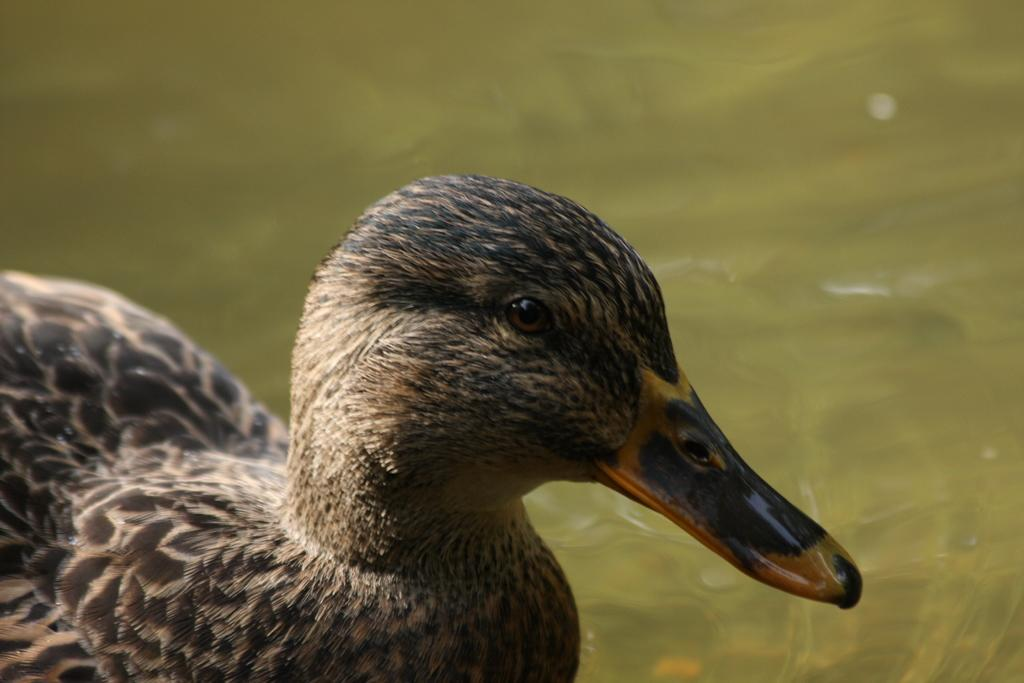What animal is present in the image? There is a duck in the image. Where is the duck located? The duck is on the water. What historical event is depicted in the image involving the duck and an oven? There is no historical event, duck, or oven present in the image. 